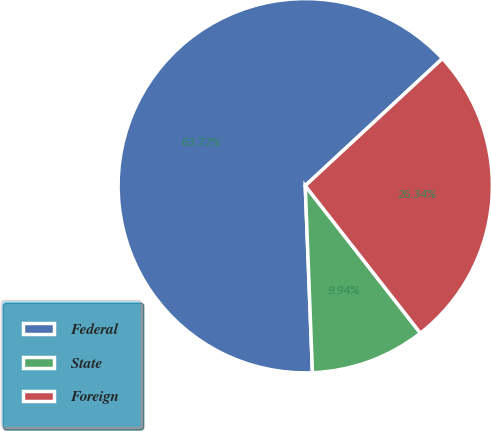Convert chart. <chart><loc_0><loc_0><loc_500><loc_500><pie_chart><fcel>Federal<fcel>State<fcel>Foreign<nl><fcel>63.71%<fcel>9.94%<fcel>26.34%<nl></chart> 